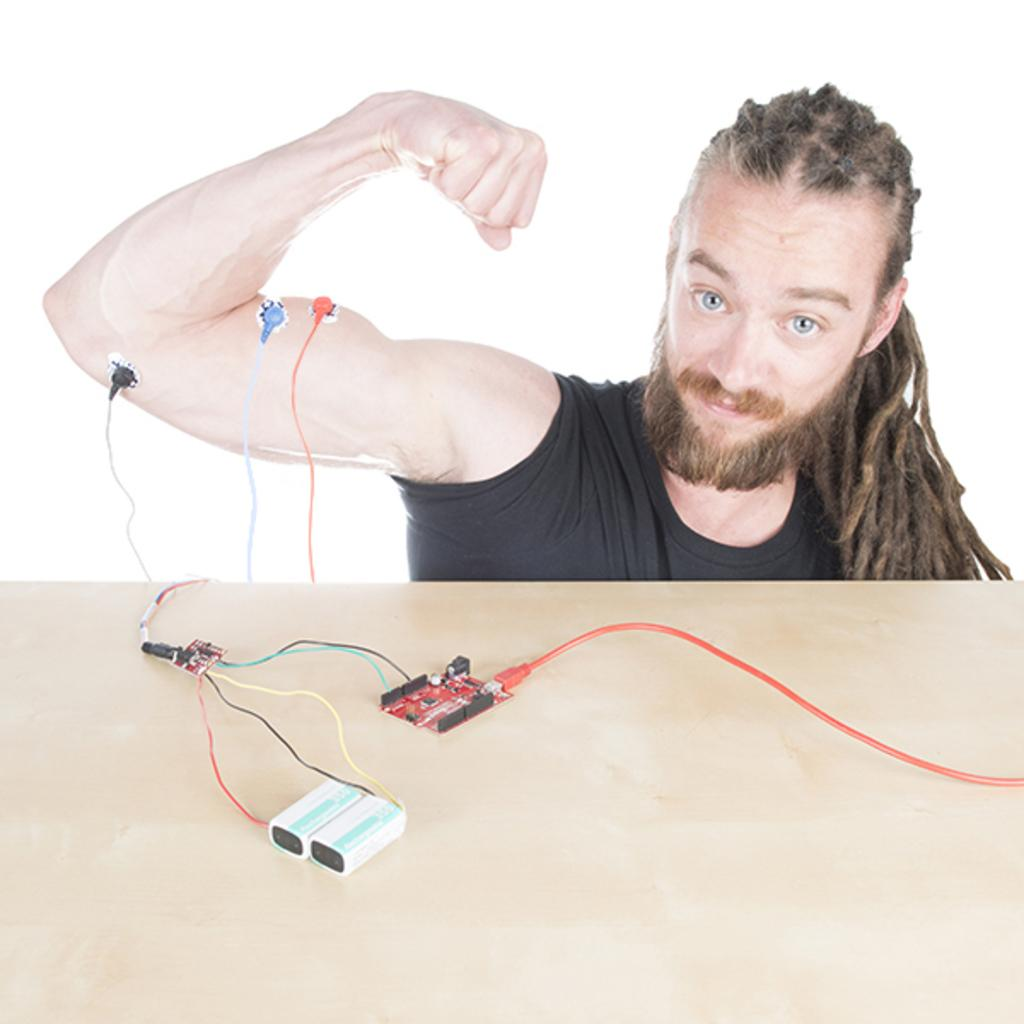What is present in the image? There is a person and a table in the image. What is the table used for in the image? The table is used to hold objects in the image. What type of health advice is the person giving to the donkey in the image? There is no donkey present in the image, and therefore no such interaction can be observed. 